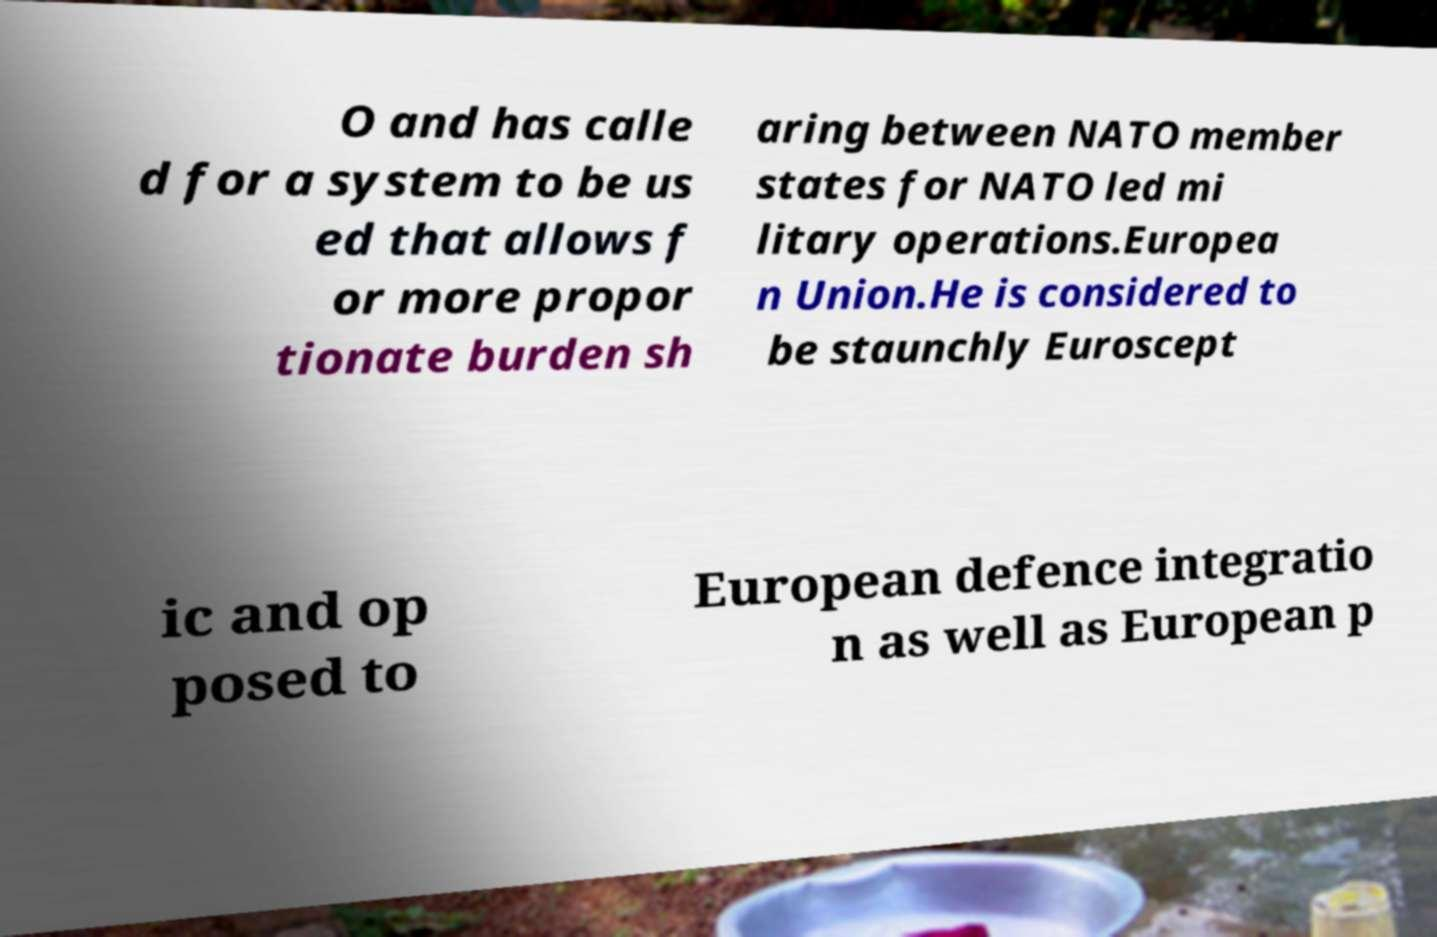I need the written content from this picture converted into text. Can you do that? O and has calle d for a system to be us ed that allows f or more propor tionate burden sh aring between NATO member states for NATO led mi litary operations.Europea n Union.He is considered to be staunchly Euroscept ic and op posed to European defence integratio n as well as European p 